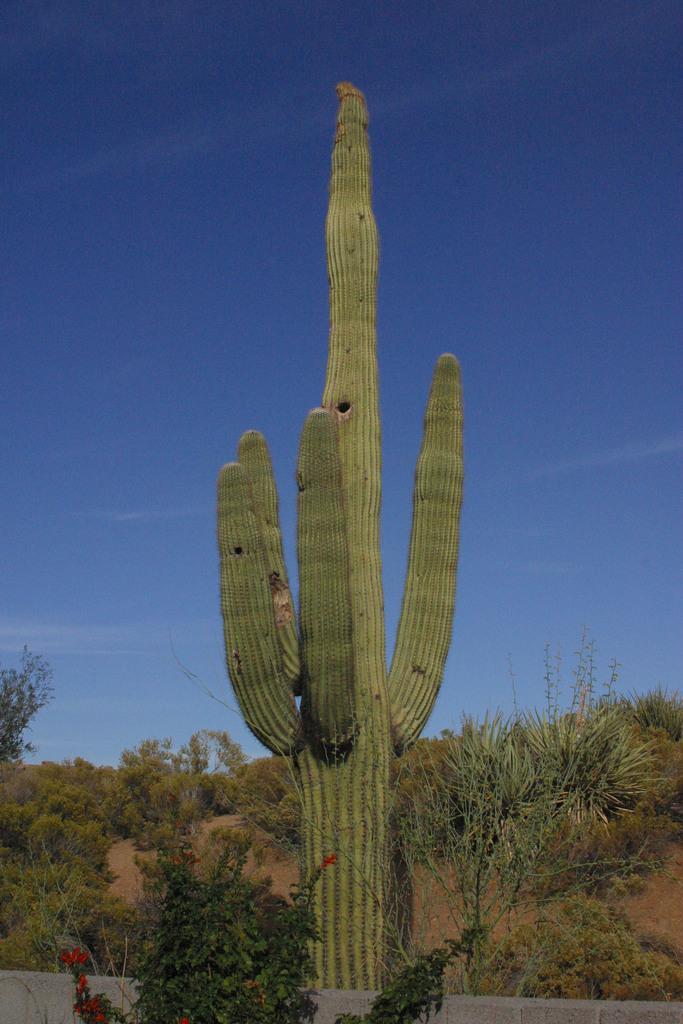Can you describe this image briefly? In the center of the image we can see a cactus and there are plants. In the background there is a tree and sky. 